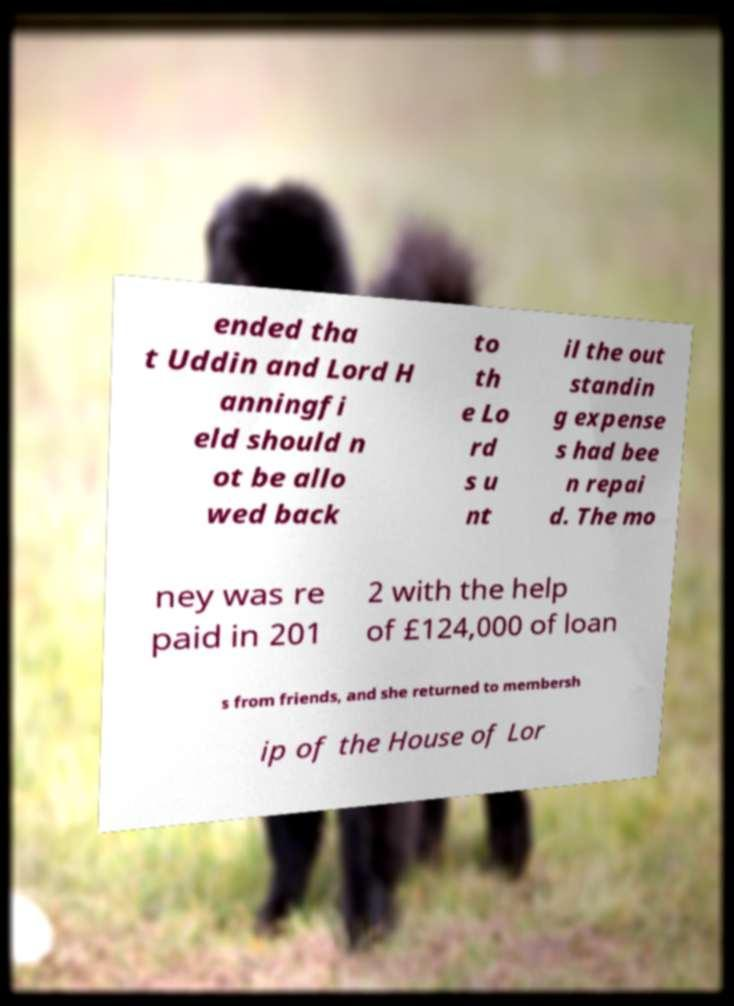Please read and relay the text visible in this image. What does it say? ended tha t Uddin and Lord H anningfi eld should n ot be allo wed back to th e Lo rd s u nt il the out standin g expense s had bee n repai d. The mo ney was re paid in 201 2 with the help of £124,000 of loan s from friends, and she returned to membersh ip of the House of Lor 